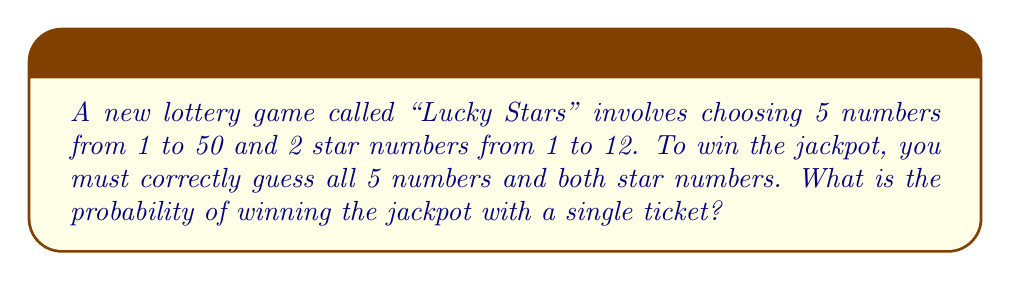Can you answer this question? To solve this problem, we'll use the multiplication principle of probability for independent events. The steps are as follows:

1. Calculate the probability of correctly guessing all 5 numbers from 1 to 50:
   - There are $\binom{50}{5}$ ways to choose 5 numbers from 50.
   - $\binom{50}{5} = \frac{50!}{5!(50-5)!} = \frac{50!}{5!45!} = 2,118,760$
   - The probability is $\frac{1}{2,118,760}$

2. Calculate the probability of correctly guessing both star numbers from 1 to 12:
   - There are $\binom{12}{2}$ ways to choose 2 numbers from 12.
   - $\binom{12}{2} = \frac{12!}{2!(12-2)!} = \frac{12!}{2!10!} = 66$
   - The probability is $\frac{1}{66}$

3. Multiply the probabilities from steps 1 and 2:
   $$P(\text{winning jackpot}) = \frac{1}{2,118,760} \times \frac{1}{66}$$

4. Simplify the fraction:
   $$P(\text{winning jackpot}) = \frac{1}{139,838,160}$$

Therefore, the probability of winning the jackpot with a single ticket is 1 in 139,838,160.
Answer: $\frac{1}{139,838,160}$ 